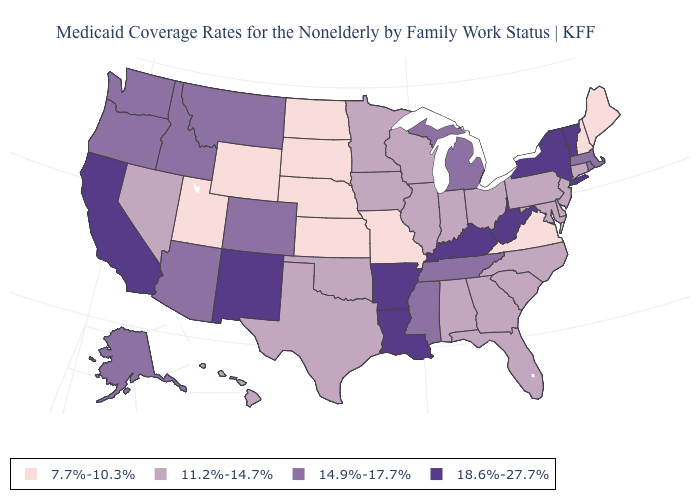What is the value of Louisiana?
Answer briefly. 18.6%-27.7%. Name the states that have a value in the range 7.7%-10.3%?
Answer briefly. Kansas, Maine, Missouri, Nebraska, New Hampshire, North Dakota, South Dakota, Utah, Virginia, Wyoming. Does the map have missing data?
Write a very short answer. No. Among the states that border West Virginia , does Kentucky have the highest value?
Short answer required. Yes. What is the value of Colorado?
Be succinct. 14.9%-17.7%. What is the value of Louisiana?
Concise answer only. 18.6%-27.7%. Among the states that border Minnesota , does North Dakota have the highest value?
Short answer required. No. What is the lowest value in states that border New Jersey?
Short answer required. 11.2%-14.7%. What is the value of Illinois?
Give a very brief answer. 11.2%-14.7%. Name the states that have a value in the range 11.2%-14.7%?
Be succinct. Alabama, Connecticut, Delaware, Florida, Georgia, Hawaii, Illinois, Indiana, Iowa, Maryland, Minnesota, Nevada, New Jersey, North Carolina, Ohio, Oklahoma, Pennsylvania, South Carolina, Texas, Wisconsin. What is the value of Oklahoma?
Give a very brief answer. 11.2%-14.7%. What is the highest value in states that border Nebraska?
Write a very short answer. 14.9%-17.7%. What is the highest value in the MidWest ?
Quick response, please. 14.9%-17.7%. 